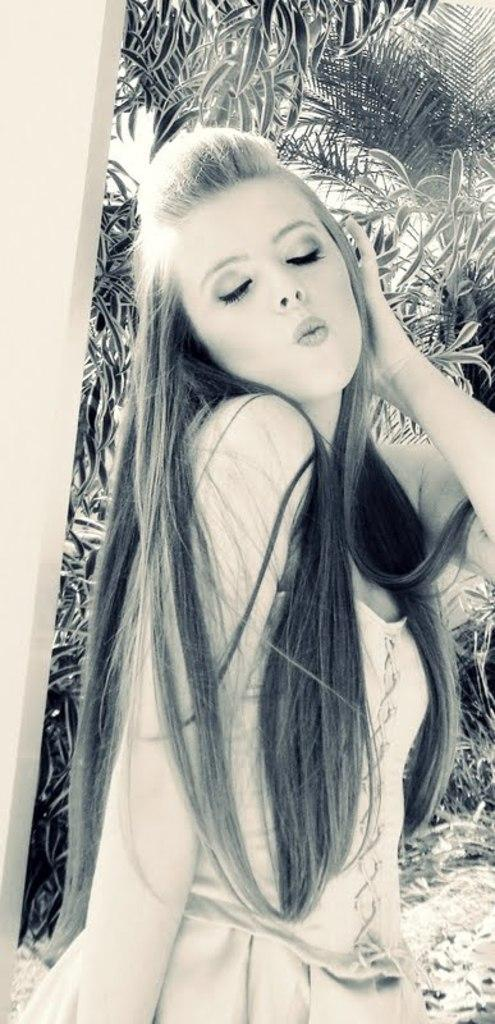What is the main subject of the image? There is a woman standing in the image. What can be seen in the background of the image? There are trees visible in the background of the image. What is the color scheme of the image? The image is in black and white. What is the manager's son doing in the image? There is no manager or son present in the image; it features a woman standing in front of trees. 